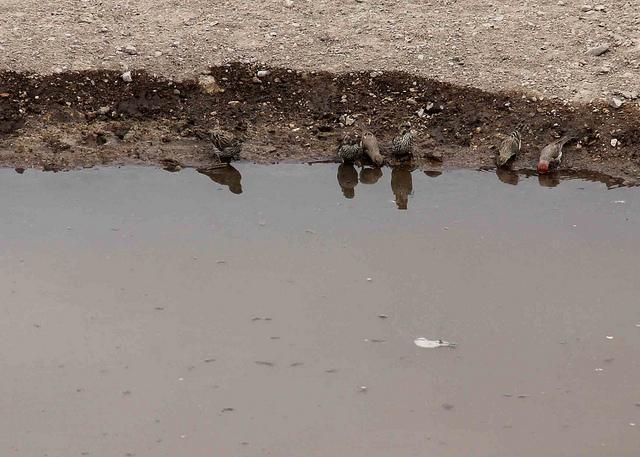How many birds are at the watering hole?
Give a very brief answer. 6. How many men are without a shirt?
Give a very brief answer. 0. 